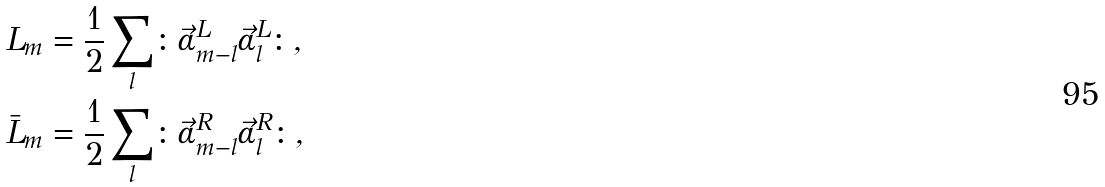Convert formula to latex. <formula><loc_0><loc_0><loc_500><loc_500>L _ { m } & = \frac { 1 } { 2 } \sum _ { l } \colon \vec { \alpha } ^ { L } _ { m - l } \vec { \alpha } ^ { L } _ { l } \colon , \\ \bar { L } _ { m } & = \frac { 1 } { 2 } \sum _ { l } \colon \vec { \alpha } ^ { R } _ { m - l } \vec { \alpha } ^ { R } _ { l } \colon ,</formula> 